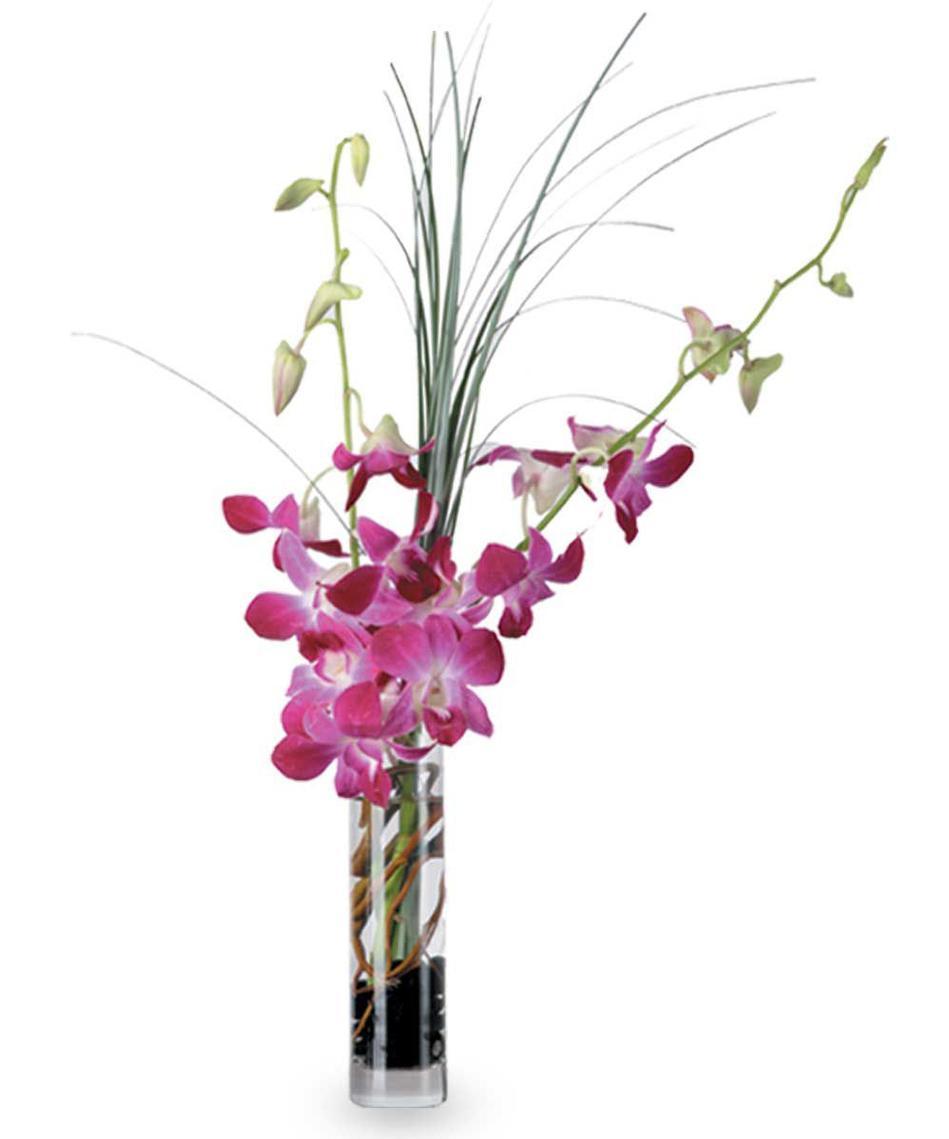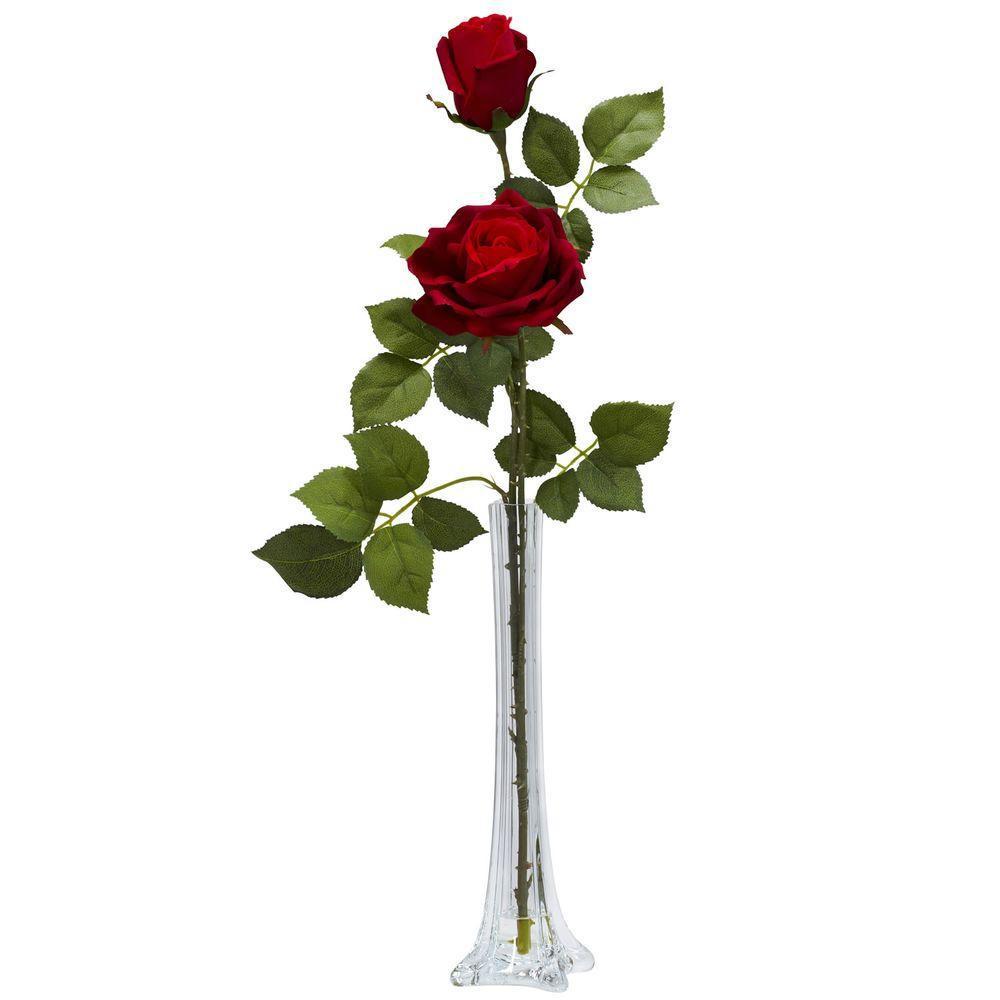The first image is the image on the left, the second image is the image on the right. Given the left and right images, does the statement "There are two vases with stems that are visible" hold true? Answer yes or no. Yes. The first image is the image on the left, the second image is the image on the right. Evaluate the accuracy of this statement regarding the images: "The flowers in the clear glass vase are white with green stems.". Is it true? Answer yes or no. No. 